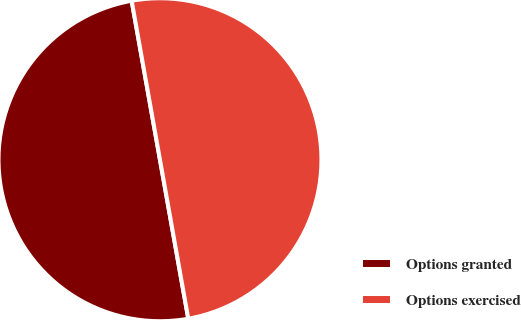Convert chart to OTSL. <chart><loc_0><loc_0><loc_500><loc_500><pie_chart><fcel>Options granted<fcel>Options exercised<nl><fcel>50.0%<fcel>50.0%<nl></chart> 